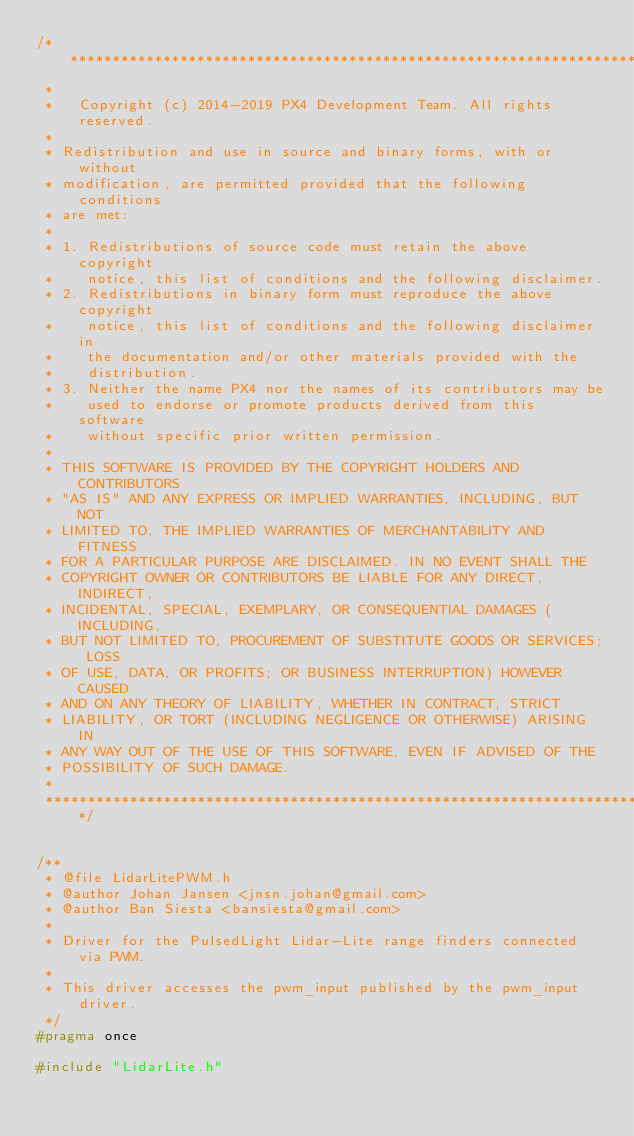<code> <loc_0><loc_0><loc_500><loc_500><_C_>/****************************************************************************
 *
 *   Copyright (c) 2014-2019 PX4 Development Team. All rights reserved.
 *
 * Redistribution and use in source and binary forms, with or without
 * modification, are permitted provided that the following conditions
 * are met:
 *
 * 1. Redistributions of source code must retain the above copyright
 *    notice, this list of conditions and the following disclaimer.
 * 2. Redistributions in binary form must reproduce the above copyright
 *    notice, this list of conditions and the following disclaimer in
 *    the documentation and/or other materials provided with the
 *    distribution.
 * 3. Neither the name PX4 nor the names of its contributors may be
 *    used to endorse or promote products derived from this software
 *    without specific prior written permission.
 *
 * THIS SOFTWARE IS PROVIDED BY THE COPYRIGHT HOLDERS AND CONTRIBUTORS
 * "AS IS" AND ANY EXPRESS OR IMPLIED WARRANTIES, INCLUDING, BUT NOT
 * LIMITED TO, THE IMPLIED WARRANTIES OF MERCHANTABILITY AND FITNESS
 * FOR A PARTICULAR PURPOSE ARE DISCLAIMED. IN NO EVENT SHALL THE
 * COPYRIGHT OWNER OR CONTRIBUTORS BE LIABLE FOR ANY DIRECT, INDIRECT,
 * INCIDENTAL, SPECIAL, EXEMPLARY, OR CONSEQUENTIAL DAMAGES (INCLUDING,
 * BUT NOT LIMITED TO, PROCUREMENT OF SUBSTITUTE GOODS OR SERVICES; LOSS
 * OF USE, DATA, OR PROFITS; OR BUSINESS INTERRUPTION) HOWEVER CAUSED
 * AND ON ANY THEORY OF LIABILITY, WHETHER IN CONTRACT, STRICT
 * LIABILITY, OR TORT (INCLUDING NEGLIGENCE OR OTHERWISE) ARISING IN
 * ANY WAY OUT OF THE USE OF THIS SOFTWARE, EVEN IF ADVISED OF THE
 * POSSIBILITY OF SUCH DAMAGE.
 *
 ****************************************************************************/


/**
 * @file LidarLitePWM.h
 * @author Johan Jansen <jnsn.johan@gmail.com>
 * @author Ban Siesta <bansiesta@gmail.com>
 *
 * Driver for the PulsedLight Lidar-Lite range finders connected via PWM.
 *
 * This driver accesses the pwm_input published by the pwm_input driver.
 */
#pragma once

#include "LidarLite.h"
</code> 